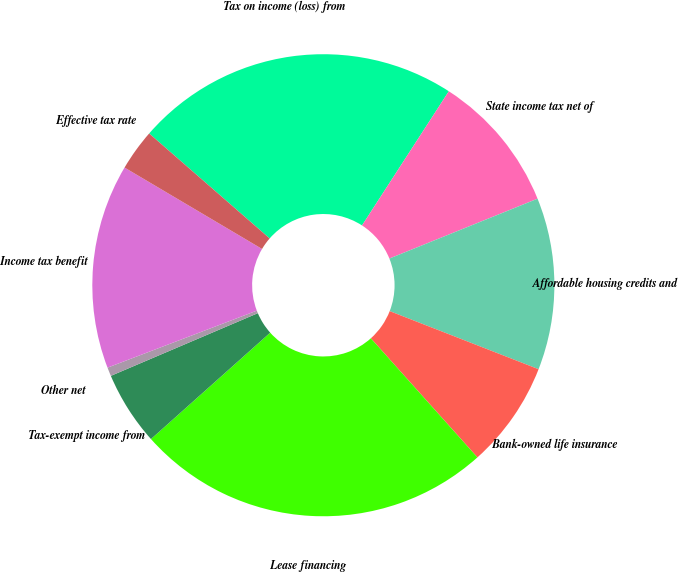Convert chart. <chart><loc_0><loc_0><loc_500><loc_500><pie_chart><fcel>Tax on income (loss) from<fcel>State income tax net of<fcel>Affordable housing credits and<fcel>Bank-owned life insurance<fcel>Lease financing<fcel>Tax-exempt income from<fcel>Other net<fcel>Income tax benefit<fcel>Effective tax rate<nl><fcel>22.73%<fcel>9.75%<fcel>12.03%<fcel>7.46%<fcel>25.02%<fcel>5.18%<fcel>0.61%<fcel>14.31%<fcel>2.9%<nl></chart> 